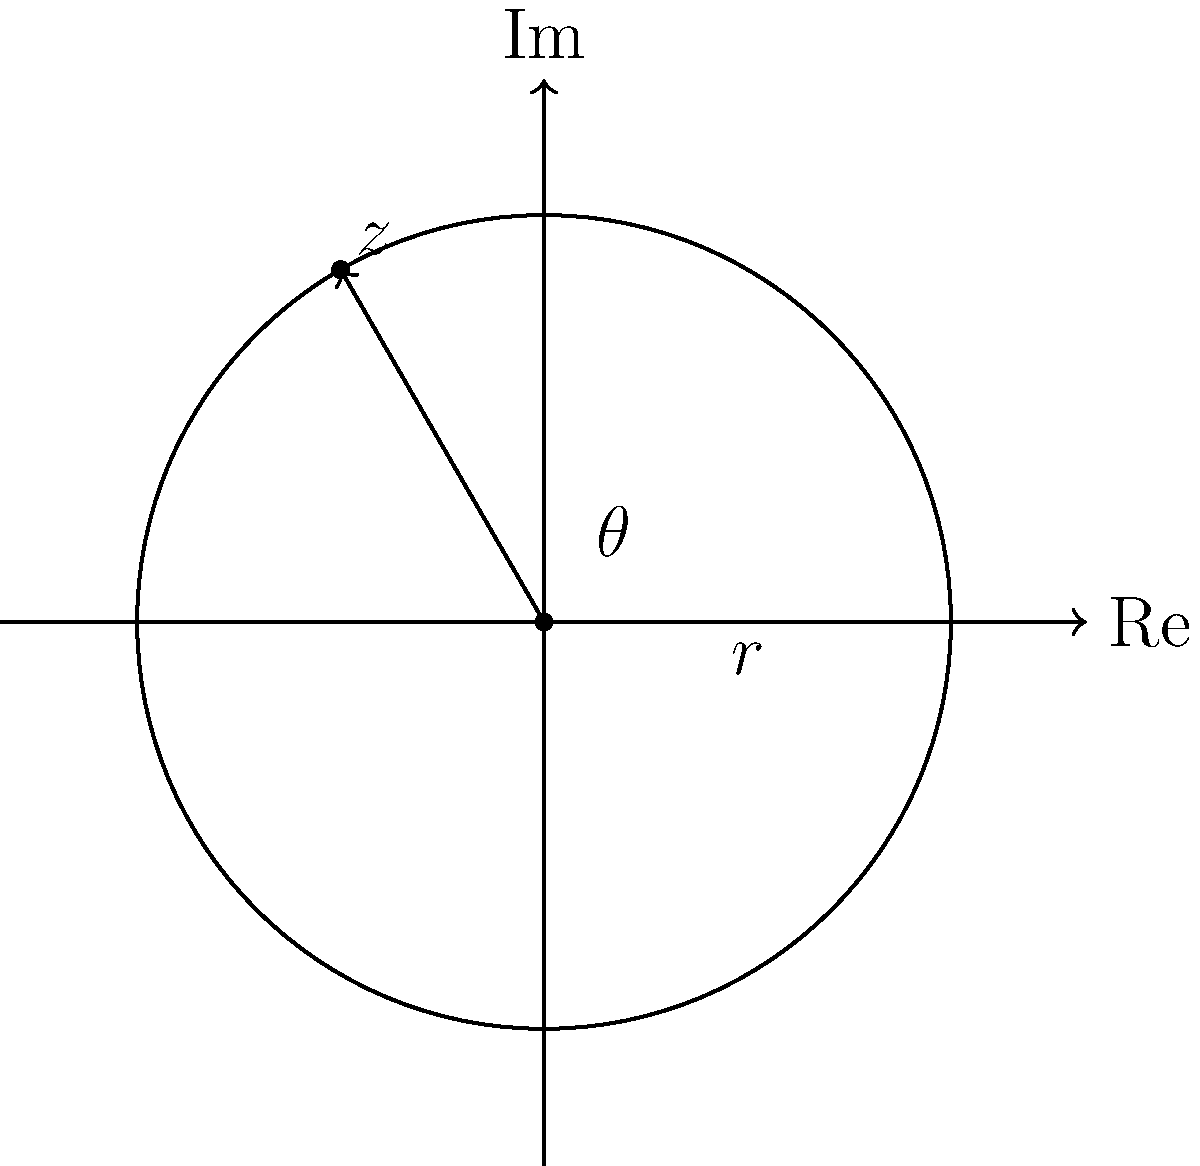Given a complex number $z = -\frac{3}{2} + i\frac{3\sqrt{3}}{2}$ represented on the Argand diagram above, calculate its phase angle $\theta$ in radians. To find the phase angle $\theta$ of the complex number $z = -\frac{3}{2} + i\frac{3\sqrt{3}}{2}$, we can follow these steps:

1) First, recognize that this complex number is in rectangular form $a + bi$.

2) To find $\theta$, we can use the arctangent function: $\theta = \arctan(\frac{b}{a})$

3) However, we need to be careful because $\arctan$ only gives values in the range $(-\frac{\pi}{2}, \frac{\pi}{2})$. Since our complex number is in the second quadrant (negative real part, positive imaginary part), we need to add $\pi$ to the result.

4) $\theta = \arctan(\frac{b}{a}) + \pi = \arctan(\frac{3\sqrt{3}/2}{-3/2}) + \pi$

5) Simplify the fraction inside $\arctan$:
   $\theta = \arctan(-\sqrt{3}) + \pi$

6) $\arctan(-\sqrt{3}) = -\frac{\pi}{3}$

7) Therefore, $\theta = -\frac{\pi}{3} + \pi = \frac{2\pi}{3}$

We can verify this result by observing that the angle in the diagram is indeed $\frac{2\pi}{3}$ or 120°.
Answer: $\frac{2\pi}{3}$ 